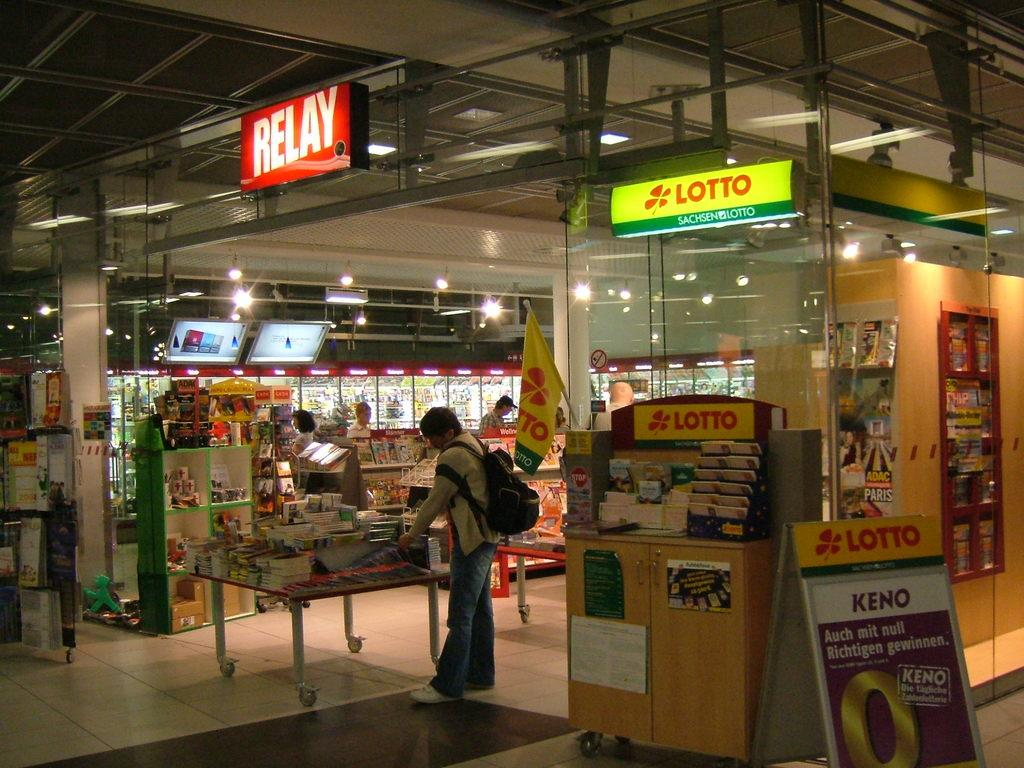<image>
Summarize the visual content of the image. A store that sells something by the brand Lotto. 